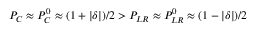<formula> <loc_0><loc_0><loc_500><loc_500>P _ { C } \approx P _ { C } ^ { 0 } \approx ( 1 + | \delta | ) / 2 > P _ { L R } \approx P _ { L R } ^ { 0 } \approx ( 1 - | \delta | ) / 2</formula> 